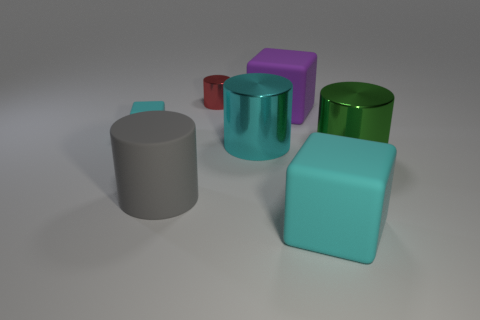The big cylinder that is made of the same material as the big purple block is what color?
Ensure brevity in your answer.  Gray. There is a cyan block that is to the right of the large gray matte cylinder; are there any big cubes that are behind it?
Offer a very short reply. Yes. What number of other things are there of the same shape as the large purple thing?
Offer a very short reply. 2. Is the shape of the cyan thing that is on the right side of the big cyan metallic object the same as the cyan thing left of the small red thing?
Your response must be concise. Yes. How many tiny cyan cubes are behind the small red metal cylinder behind the big rubber cube in front of the tiny block?
Ensure brevity in your answer.  0. The small rubber block has what color?
Keep it short and to the point. Cyan. What number of other things are there of the same size as the cyan cylinder?
Your answer should be compact. 4. There is a purple object that is the same shape as the tiny cyan rubber thing; what is its material?
Ensure brevity in your answer.  Rubber. There is a cyan block in front of the large metal cylinder that is on the right side of the cyan metal thing that is to the right of the gray object; what is it made of?
Give a very brief answer. Rubber. What size is the purple object that is the same material as the large gray thing?
Your response must be concise. Large. 